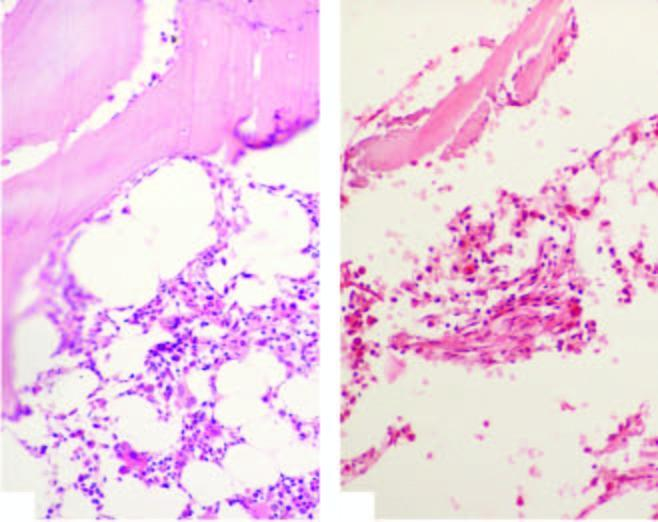what is bone marrow trephine biopsy in aplastic anaemia contrasted against?
Answer the question using a single word or phrase. Normal cellular marrow 